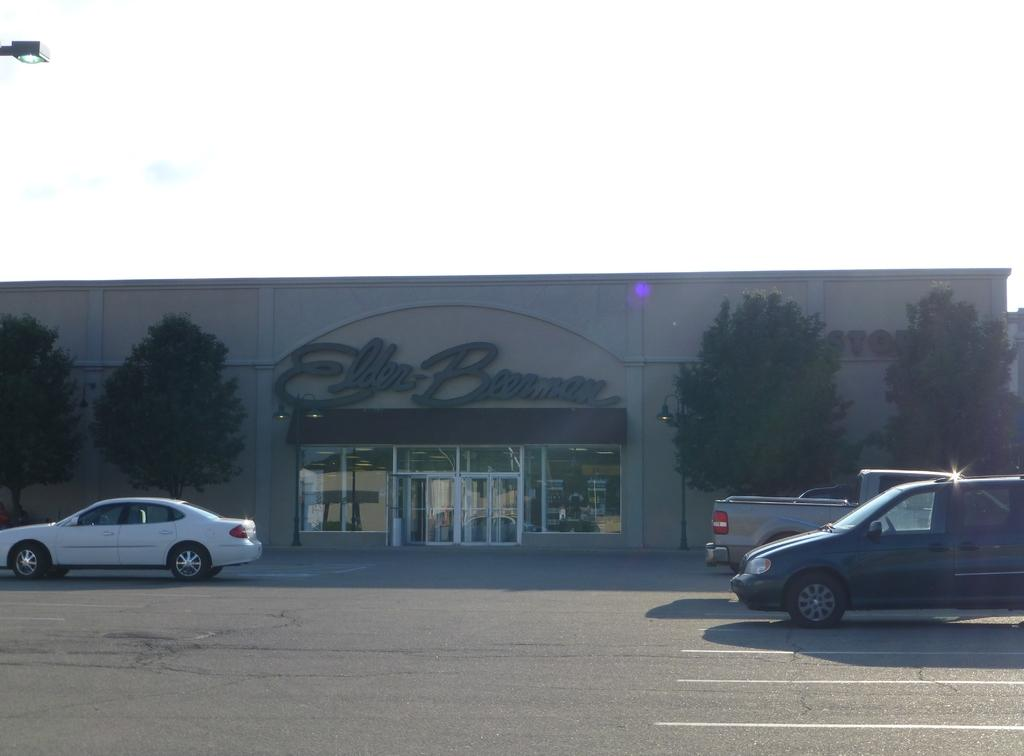What can be seen on the road in the image? There are vehicles on the road in the image. What is visible in the background of the image? The sky, clouds, trees, at least one building, a wall, and a banner are visible in the background of the image. What material is present in the background of the image? Glass is visible in the background of the image. How many spiders are crawling on the vehicles in the image? There are no spiders present in the image; it features vehicles on the road with a background containing the sky, clouds, trees, buildings, wall, and banner. 